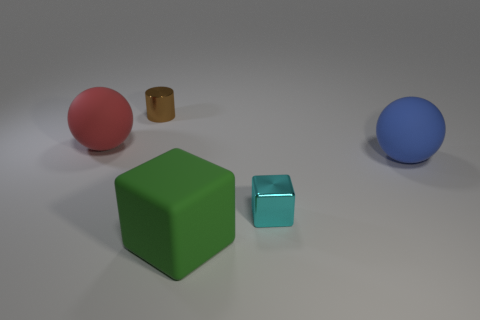Is there anything else of the same color as the large matte block?
Offer a very short reply. No. Are any big red objects visible?
Your answer should be compact. Yes. Is there a cyan cube made of the same material as the small brown object?
Keep it short and to the point. Yes. Is there anything else that is made of the same material as the cyan object?
Offer a terse response. Yes. What color is the rubber cube?
Provide a short and direct response. Green. What color is the matte sphere that is the same size as the red rubber object?
Keep it short and to the point. Blue. How many rubber things are either small purple balls or big blue objects?
Your answer should be compact. 1. How many balls are left of the brown metallic object and right of the big green rubber thing?
Your answer should be compact. 0. Is there any other thing that is the same shape as the red matte object?
Offer a very short reply. Yes. How many other things are the same size as the brown cylinder?
Provide a short and direct response. 1. 